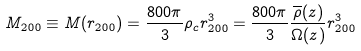<formula> <loc_0><loc_0><loc_500><loc_500>M _ { 2 0 0 } \equiv M ( r _ { 2 0 0 } ) = \frac { 8 0 0 \pi } { 3 } \rho _ { c } r _ { 2 0 0 } ^ { 3 } = \frac { 8 0 0 \pi } { 3 } \frac { \overline { \rho } ( z ) } { \Omega ( z ) } r _ { 2 0 0 } ^ { 3 }</formula> 